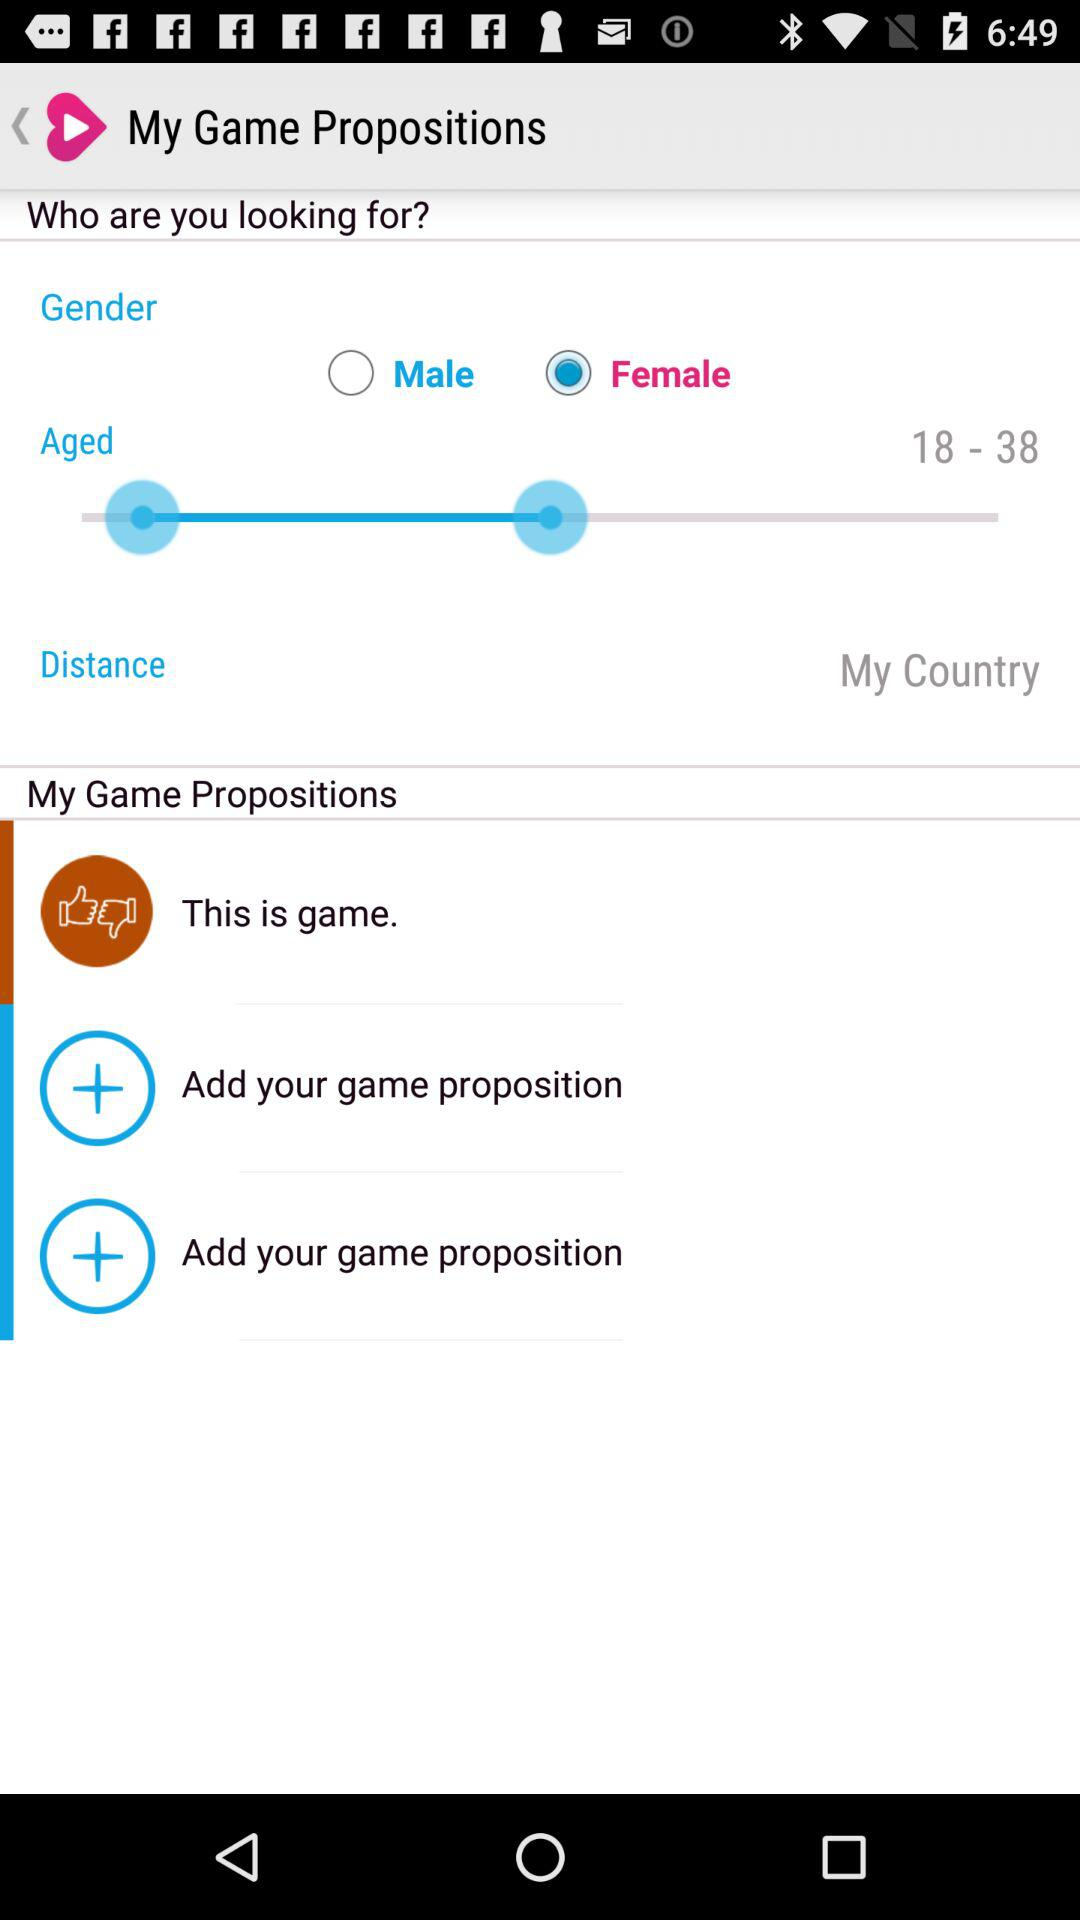What is the application name?
When the provided information is insufficient, respond with <no answer>. <no answer> 